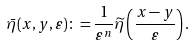<formula> <loc_0><loc_0><loc_500><loc_500>\bar { \eta } ( x , y , \varepsilon ) \colon = \frac { 1 } { \varepsilon ^ { n } } \widetilde { \eta } \left ( \frac { x - y } { \varepsilon } \right ) .</formula> 